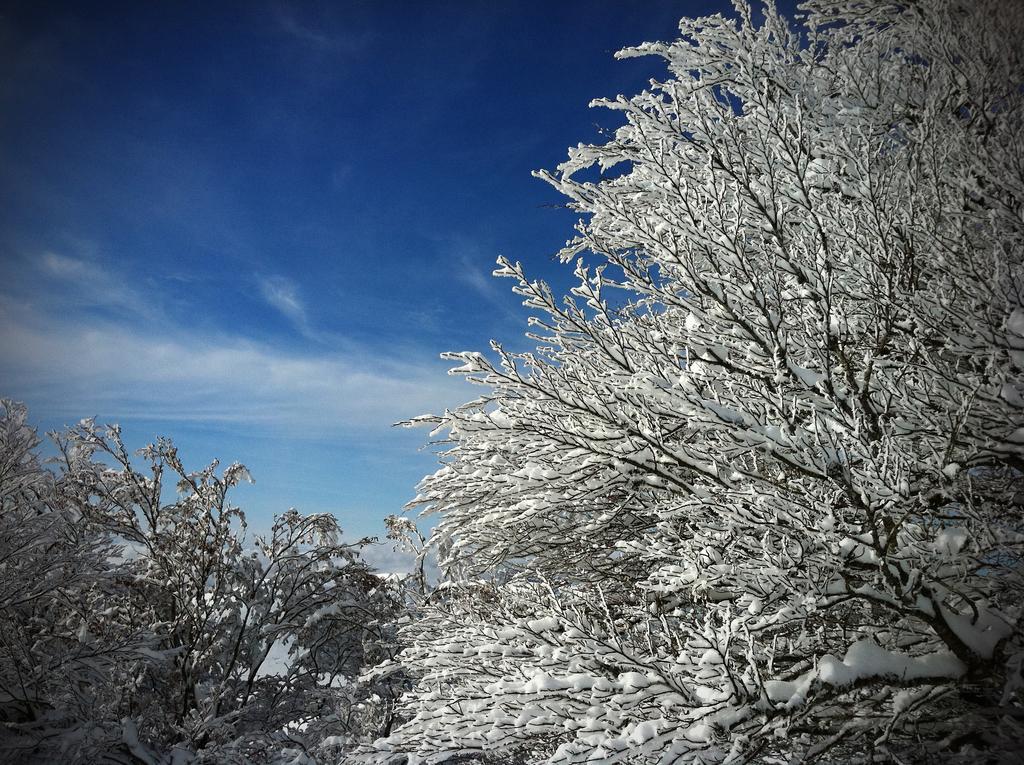Describe this image in one or two sentences. In this picture we can see trees, there is snow on the branches of these trees, we can see the sky and clouds in the background. 